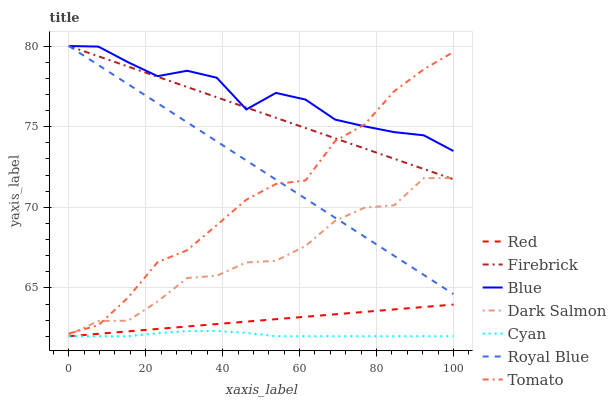Does Cyan have the minimum area under the curve?
Answer yes or no. Yes. Does Blue have the maximum area under the curve?
Answer yes or no. Yes. Does Tomato have the minimum area under the curve?
Answer yes or no. No. Does Tomato have the maximum area under the curve?
Answer yes or no. No. Is Firebrick the smoothest?
Answer yes or no. Yes. Is Blue the roughest?
Answer yes or no. Yes. Is Tomato the smoothest?
Answer yes or no. No. Is Tomato the roughest?
Answer yes or no. No. Does Cyan have the lowest value?
Answer yes or no. Yes. Does Tomato have the lowest value?
Answer yes or no. No. Does Royal Blue have the highest value?
Answer yes or no. Yes. Does Tomato have the highest value?
Answer yes or no. No. Is Red less than Dark Salmon?
Answer yes or no. Yes. Is Royal Blue greater than Cyan?
Answer yes or no. Yes. Does Firebrick intersect Royal Blue?
Answer yes or no. Yes. Is Firebrick less than Royal Blue?
Answer yes or no. No. Is Firebrick greater than Royal Blue?
Answer yes or no. No. Does Red intersect Dark Salmon?
Answer yes or no. No. 